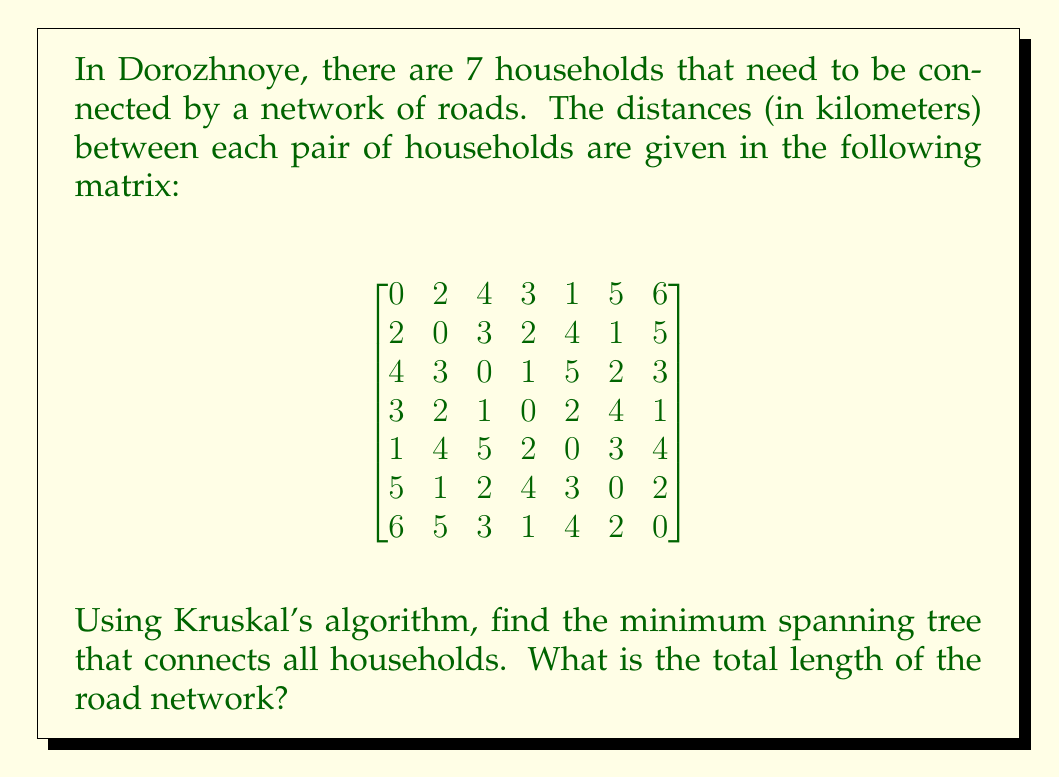Show me your answer to this math problem. To solve this problem, we'll use Kruskal's algorithm to find the minimum spanning tree:

1. Sort all edges in ascending order of weight (distance):
   (2,6): 1, (3,4): 1, (1,5): 1, (2,5): 1, (3,6): 2, (4,7): 1, (1,2): 2, ...

2. Start with an empty set of edges and add edges one by one, avoiding cycles:

   a. Add (2,6): 1
   b. Add (3,4): 1
   c. Add (1,5): 1
   d. Add (4,7): 1
   e. Add (3,6): 2
   f. Add (1,2): 2

3. After adding these 6 edges, we have connected all 7 vertices without creating any cycles.

The minimum spanning tree is:

[asy]
unitsize(30);
pair[] v = {(0,0), (2,1), (1,2), (-1,1), (-2,-1), (0,-2), (2,-1)};
for(int i=0; i<7; ++i) {
  dot(v[i]);
  label("$" + string(i+1) + "$", v[i], E);
}
draw(v[1]--v[5]);
draw(v[2]--v[3]);
draw(v[0]--v[4]);
draw(v[3]--v[6]);
draw(v[2]--v[5]);
draw(v[0]--v[1]);
[/asy]

4. Calculate the total length of the road network:
   1 + 1 + 1 + 1 + 2 + 2 = 8 km
Answer: The total length of the minimum spanning tree (road network) is 8 km. 